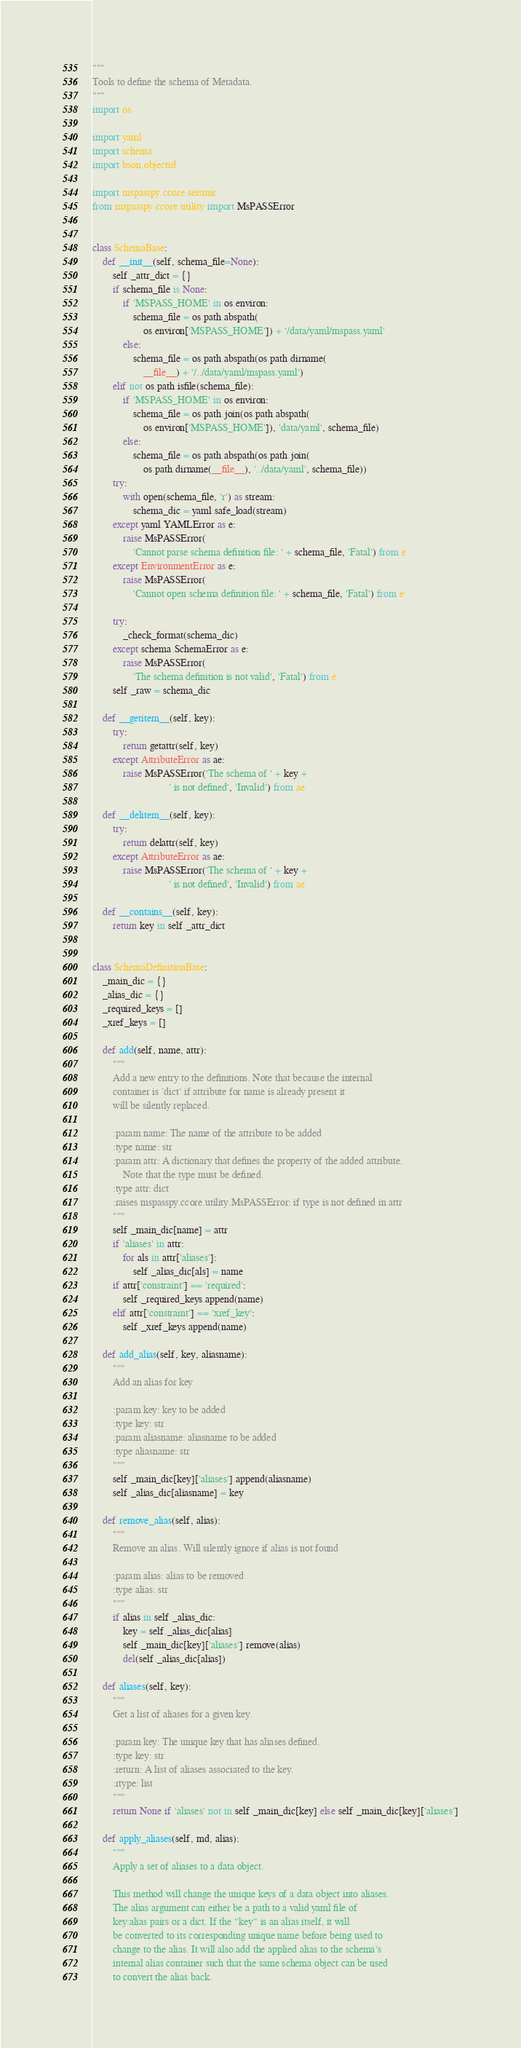<code> <loc_0><loc_0><loc_500><loc_500><_Python_>"""
Tools to define the schema of Metadata.
"""
import os

import yaml
import schema
import bson.objectid

import mspasspy.ccore.seismic
from mspasspy.ccore.utility import MsPASSError


class SchemaBase:
    def __init__(self, schema_file=None):
        self._attr_dict = {}
        if schema_file is None:
            if 'MSPASS_HOME' in os.environ:
                schema_file = os.path.abspath(
                    os.environ['MSPASS_HOME']) + '/data/yaml/mspass.yaml'
            else:
                schema_file = os.path.abspath(os.path.dirname(
                    __file__) + '/../data/yaml/mspass.yaml')
        elif not os.path.isfile(schema_file):
            if 'MSPASS_HOME' in os.environ:
                schema_file = os.path.join(os.path.abspath(
                    os.environ['MSPASS_HOME']), 'data/yaml', schema_file)
            else:
                schema_file = os.path.abspath(os.path.join(
                    os.path.dirname(__file__), '../data/yaml', schema_file))
        try:
            with open(schema_file, 'r') as stream:
                schema_dic = yaml.safe_load(stream)
        except yaml.YAMLError as e:
            raise MsPASSError(
                'Cannot parse schema definition file: ' + schema_file, 'Fatal') from e
        except EnvironmentError as e:
            raise MsPASSError(
                'Cannot open schema definition file: ' + schema_file, 'Fatal') from e

        try:
            _check_format(schema_dic)
        except schema.SchemaError as e:
            raise MsPASSError(
                'The schema definition is not valid', 'Fatal') from e
        self._raw = schema_dic

    def __getitem__(self, key):
        try:
            return getattr(self, key)
        except AttributeError as ae:
            raise MsPASSError('The schema of ' + key +
                              ' is not defined', 'Invalid') from ae

    def __delitem__(self, key):
        try:
            return delattr(self, key)
        except AttributeError as ae:
            raise MsPASSError('The schema of ' + key +
                              ' is not defined', 'Invalid') from ae

    def __contains__(self, key):
        return key in self._attr_dict


class SchemaDefinitionBase:
    _main_dic = {}
    _alias_dic = {}
    _required_keys = []
    _xref_keys = []

    def add(self, name, attr):
        """
        Add a new entry to the definitions. Note that because the internal
        container is `dict` if attribute for name is already present it
        will be silently replaced.

        :param name: The name of the attribute to be added
        :type name: str
        :param attr: A dictionary that defines the property of the added attribute.
            Note that the type must be defined.
        :type attr: dict
        :raises mspasspy.ccore.utility.MsPASSError: if type is not defined in attr
        """
        self._main_dic[name] = attr
        if 'aliases' in attr:
            for als in attr['aliases']:
                self._alias_dic[als] = name
        if attr['constraint'] == 'required':
            self._required_keys.append(name)
        elif attr['constraint'] == 'xref_key':
            self._xref_keys.append(name)

    def add_alias(self, key, aliasname):
        """
        Add an alias for key

        :param key: key to be added
        :type key: str
        :param aliasname: aliasname to be added
        :type aliasname: str
        """
        self._main_dic[key]['aliases'].append(aliasname)
        self._alias_dic[aliasname] = key

    def remove_alias(self, alias):
        """
        Remove an alias. Will silently ignore if alias is not found

        :param alias: alias to be removed
        :type alias: str
        """
        if alias in self._alias_dic:
            key = self._alias_dic[alias]
            self._main_dic[key]['aliases'].remove(alias)
            del(self._alias_dic[alias])

    def aliases(self, key):
        """
        Get a list of aliases for a given key.

        :param key: The unique key that has aliases defined.
        :type key: str
        :return: A list of aliases associated to the key.
        :rtype: list
        """
        return None if 'aliases' not in self._main_dic[key] else self._main_dic[key]['aliases']

    def apply_aliases(self, md, alias):
        """
        Apply a set of aliases to a data object.

        This method will change the unique keys of a data object into aliases. 
        The alias argument can either be a path to a valid yaml file of 
        key:alias pairs or a dict. If the "key" is an alias itself, it will
        be converted to its corresponding unique name before being used to 
        change to the alias. It will also add the applied alias to the schema's
        internal alias container such that the same schema object can be used
        to convert the alias back.
</code> 